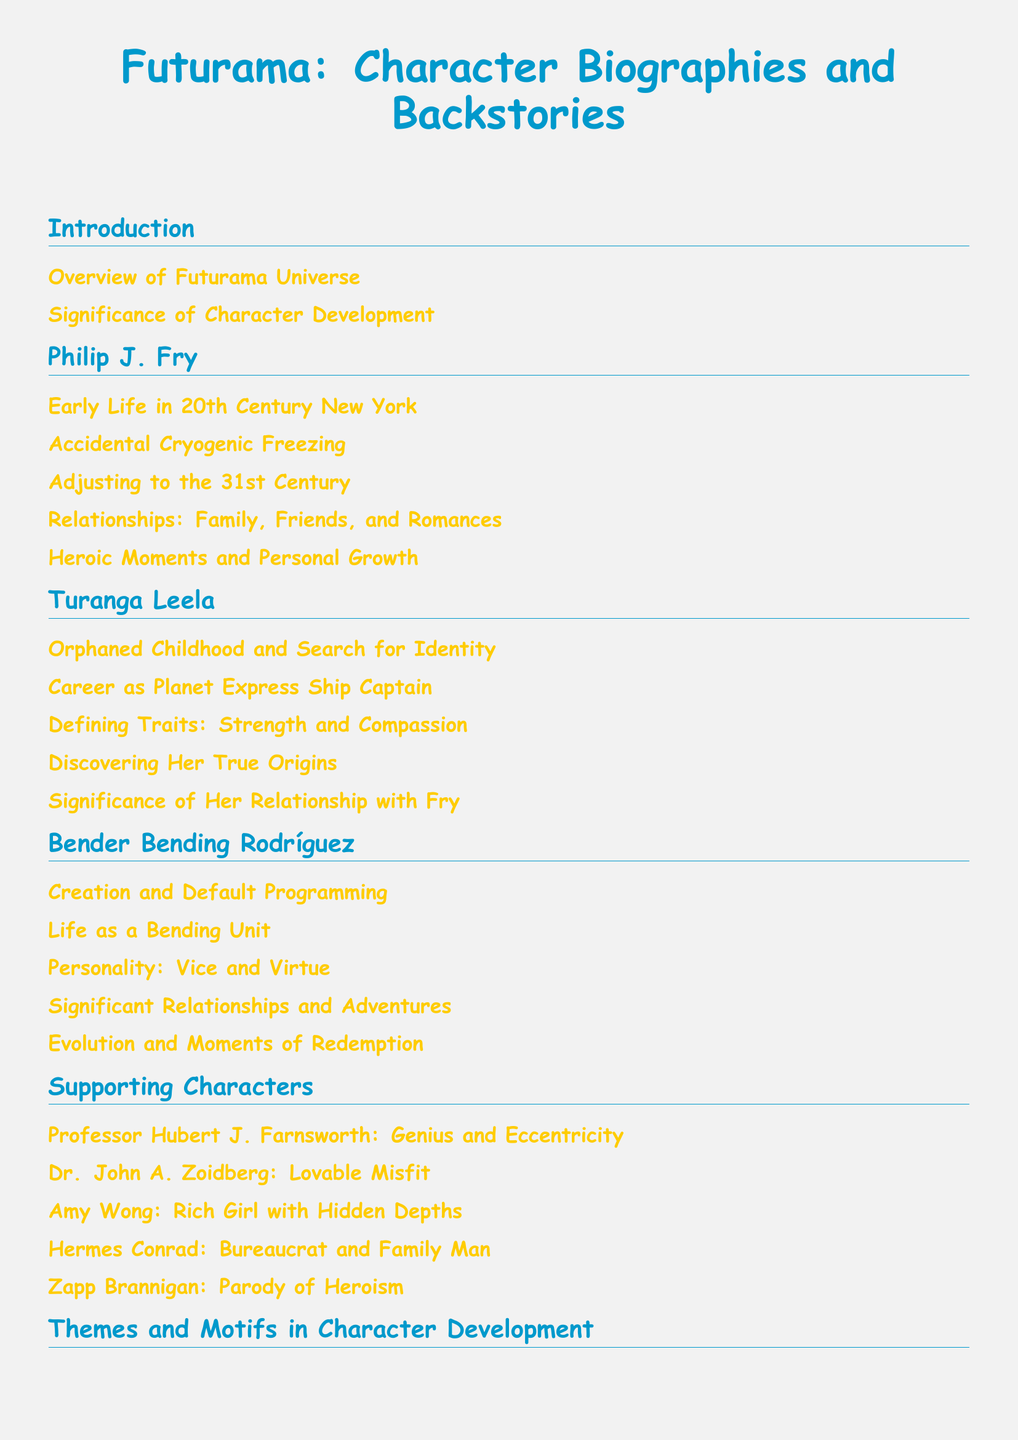What is the title of the document? The title reflects the main focus of the text, which is character biographies and backstories in the Futurama universe.
Answer: Futurama: Character Biographies and Backstories Who is the main character discussed in the first section? The first character biography presented in the document is about Philip J. Fry.
Answer: Philip J. Fry How many subsections are dedicated to Turanga Leela? The document contains multiple subsections that provide an in-depth look at her character development.
Answer: 5 What relationship between characters is emphasized in Leela's section? The document highlights the importance of her relationship with another major character.
Answer: Her relationship with Fry Which character is noted for their personality traits of vice and virtue? The characterization of this individual shows a mix of morally ambiguous traits with glimpses of goodness.
Answer: Bender Bending Rodríguez What is a significant theme discussed regarding character development? The document explores various profound themes related to characters' growth and evolution.
Answer: Exploration of Identity and Existentialism Which character is described as a "Lovable Misfit"? This phrase indicates an endearing quality of the character, presenting them as both quirky and relatable.
Answer: Dr. John A. Zoidberg What color is used for the section titles in the document? The color choice for the titles adds a vibrant and thematic visual element to the document.
Answer: Futurama Blue 